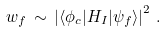<formula> <loc_0><loc_0><loc_500><loc_500>w _ { f } \, \sim \, \left | \langle \phi _ { c } | H _ { I } | \psi _ { f } \rangle \right | ^ { 2 } \, .</formula> 